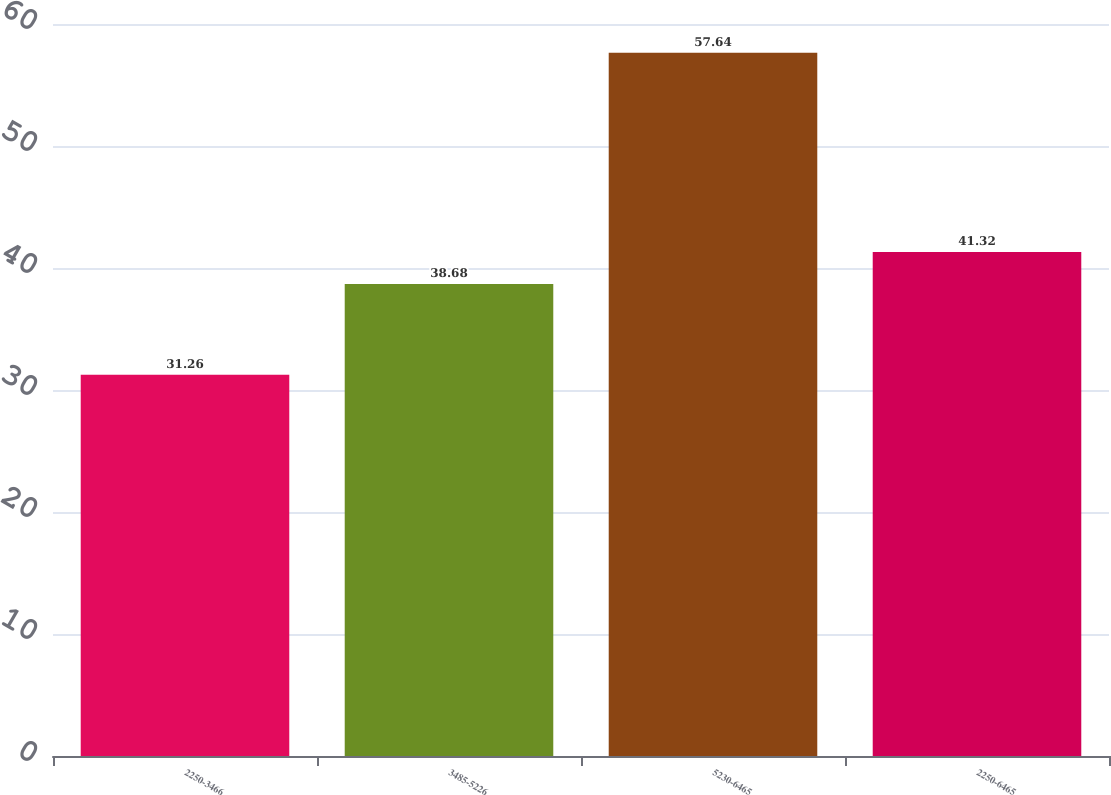Convert chart to OTSL. <chart><loc_0><loc_0><loc_500><loc_500><bar_chart><fcel>2250-3466<fcel>3485-5226<fcel>5230-6465<fcel>2250-6465<nl><fcel>31.26<fcel>38.68<fcel>57.64<fcel>41.32<nl></chart> 